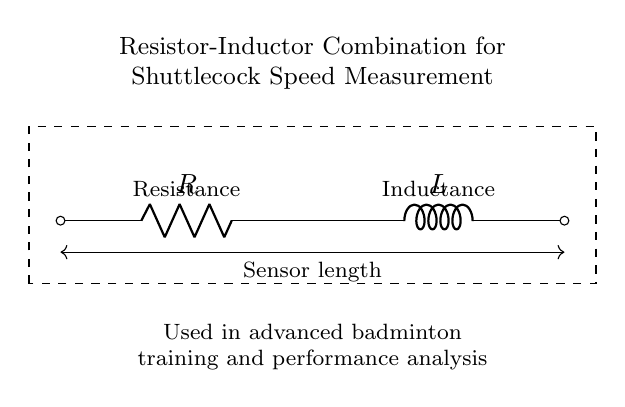What components are present in this circuit? The circuit diagram displays a resistor and an inductor, with labels indicating their respective components.
Answer: Resistor and inductor What does the dashed rectangle indicate? The dashed rectangle encloses the resistor-inductor combination, highlighting the area of interest for shuttlecock speed measurement.
Answer: Area of interest What type of circuit is depicted here? The diagram features a series combination of a resistor and an inductor as indicated by their sequential connection in a single path.
Answer: Series circuit What is the purpose of this resistor-inductor combination? The circuit is designed for shuttlecock speed measurement in badminton training, focusing on the analysis of performance using electrical components.
Answer: Speed measurement How does the resistance affect the circuit? Resistance determines the amount of current flowing through the circuit according to Ohm's law; it impacts the time constant in the resistor-inductor combination.
Answer: Affects current flow Why is an inductor used in this measurement device? Inductors store energy in a magnetic field and can affect the phase of the current, providing more precise measurements of the shuttlecock's speed over time.
Answer: For precise measurements What is the significance of the sensor length in this circuit? The sensor length relates to the overall dimensions of the measuring device and influences the characteristics of the resistor-inductor circuit, affecting measurement accuracy.
Answer: Influences measurement accuracy 